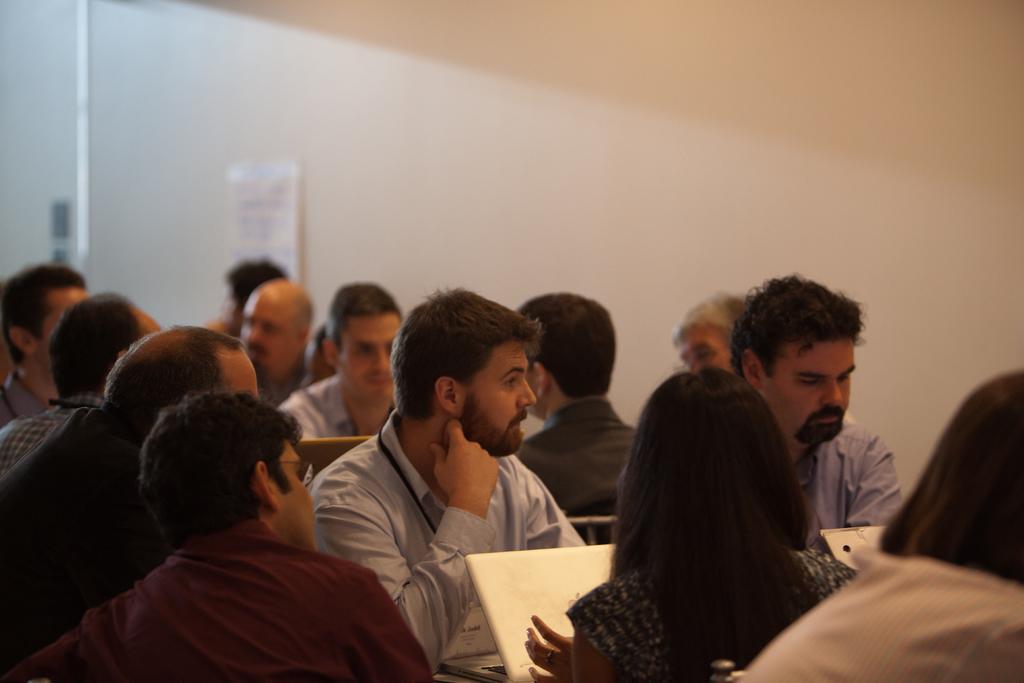How would you summarize this image in a sentence or two? In this picture I can observe some people sitting on the chairs in the middle of the picture. There are men and women in this picture. In the background I can observe wall. 